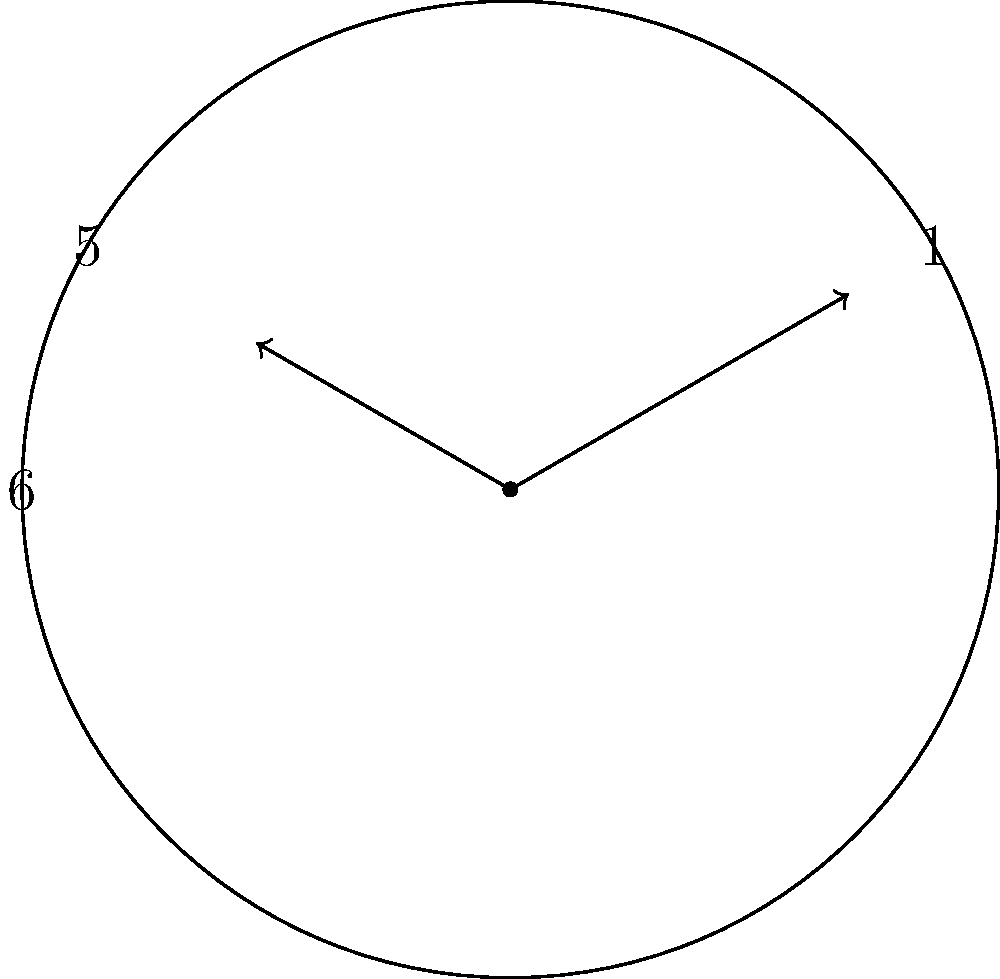During a family dinner at 5:05, you decide to teach your child about clock angles. What is the acute angle formed between the hour and minute hands at this time? Let's approach this step-by-step:

1) First, we need to calculate the angle made by each hand from the 12 o'clock position:

   For the hour hand:
   - In 1 hour, the hour hand rotates 30° (360° / 12)
   - In 5 hours, it rotates 5 * 30° = 150°
   - In 5 minutes, it rotates an additional 5/60 * 30° = 2.5°
   - Total angle for hour hand: 150° + 2.5° = 152.5°

   For the minute hand:
   - In 1 minute, the minute hand rotates 6° (360° / 60)
   - In 5 minutes, it rotates 5 * 6° = 30°

2) The angle between the hands is the absolute difference:
   $|152.5° - 30°| = 122.5°$

3) However, we need the acute angle. If the angle is greater than 180°, we subtract it from 360°:
   122.5° is less than 180°, so this is our acute angle.

Therefore, the acute angle between the hour and minute hands at 5:05 is 122.5°.
Answer: 122.5° 